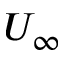<formula> <loc_0><loc_0><loc_500><loc_500>U _ { \infty }</formula> 